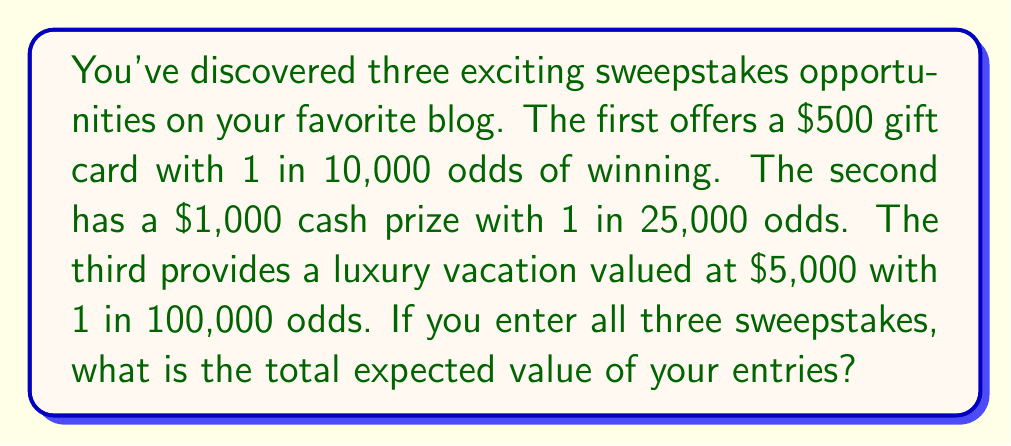Can you solve this math problem? To solve this problem, we need to calculate the expected value of each sweepstake and then sum them up. The expected value is calculated by multiplying the prize value by the probability of winning.

1. For the $500 gift card sweepstake:
   Probability of winning = $\frac{1}{10,000} = 0.0001$
   Expected value = $500 \times 0.0001 = $0.05$

2. For the $1,000 cash prize sweepstake:
   Probability of winning = $\frac{1}{25,000} = 0.00004$
   Expected value = $1,000 \times 0.00004 = $0.04$

3. For the $5,000 luxury vacation sweepstake:
   Probability of winning = $\frac{1}{100,000} = 0.00001$
   Expected value = $5,000 \times 0.00001 = $0.05$

Now, we sum up the expected values of all three sweepstakes:

Total expected value = $0.05 + $0.04 + $0.05 = $0.14$

Therefore, the total expected value of entering all three sweepstakes is $0.14.
Answer: $0.14 